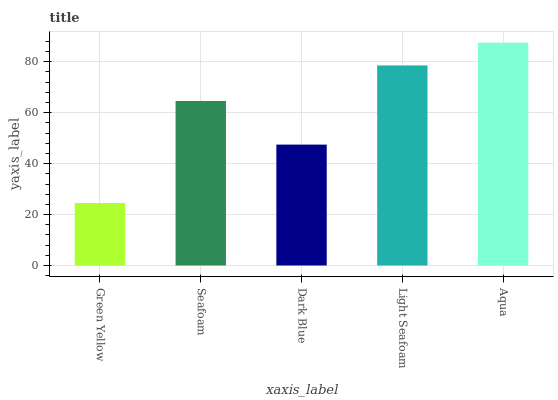Is Green Yellow the minimum?
Answer yes or no. Yes. Is Aqua the maximum?
Answer yes or no. Yes. Is Seafoam the minimum?
Answer yes or no. No. Is Seafoam the maximum?
Answer yes or no. No. Is Seafoam greater than Green Yellow?
Answer yes or no. Yes. Is Green Yellow less than Seafoam?
Answer yes or no. Yes. Is Green Yellow greater than Seafoam?
Answer yes or no. No. Is Seafoam less than Green Yellow?
Answer yes or no. No. Is Seafoam the high median?
Answer yes or no. Yes. Is Seafoam the low median?
Answer yes or no. Yes. Is Light Seafoam the high median?
Answer yes or no. No. Is Aqua the low median?
Answer yes or no. No. 